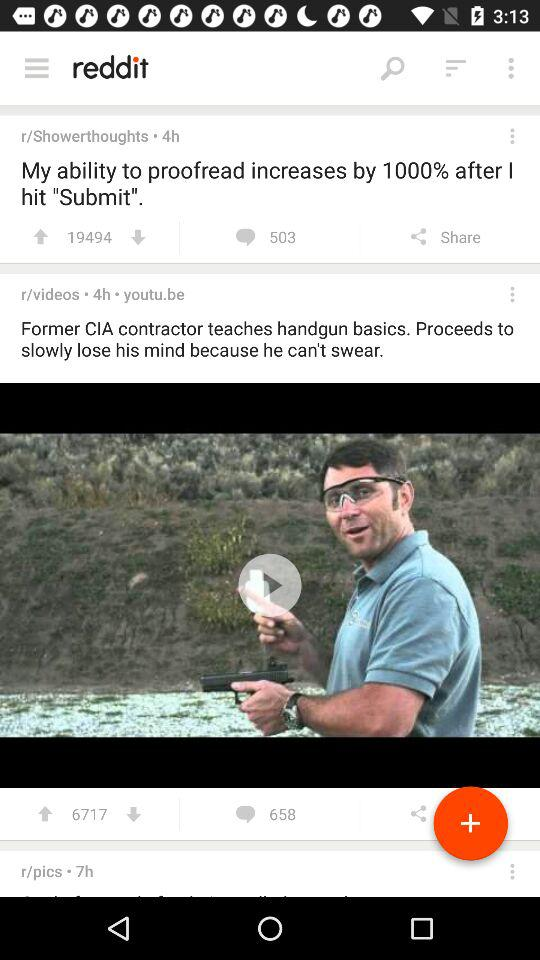How many comments are received on "r/Showerthoughts" post? There are 503 comments on the post. 